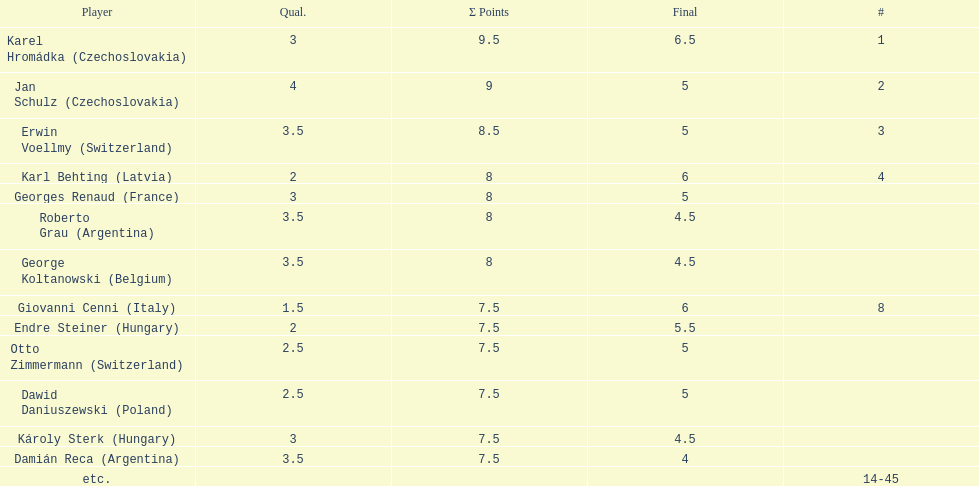How many countries had more than one player in the consolation cup? 4. 